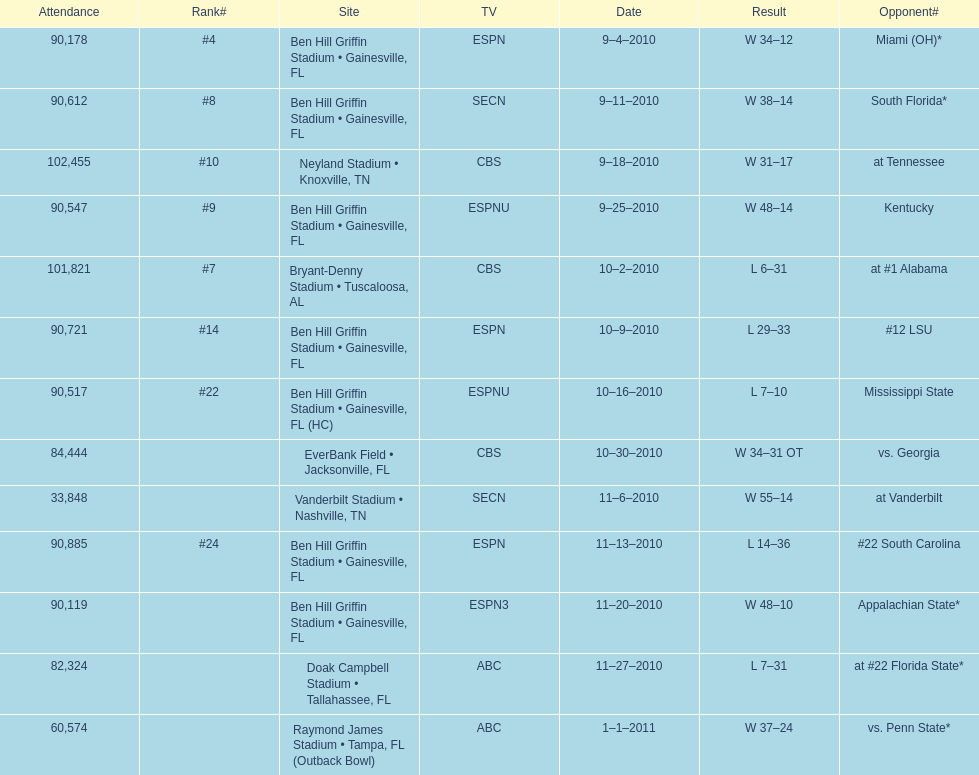What tv network showed the largest number of games during the 2010/2011 season? ESPN. 